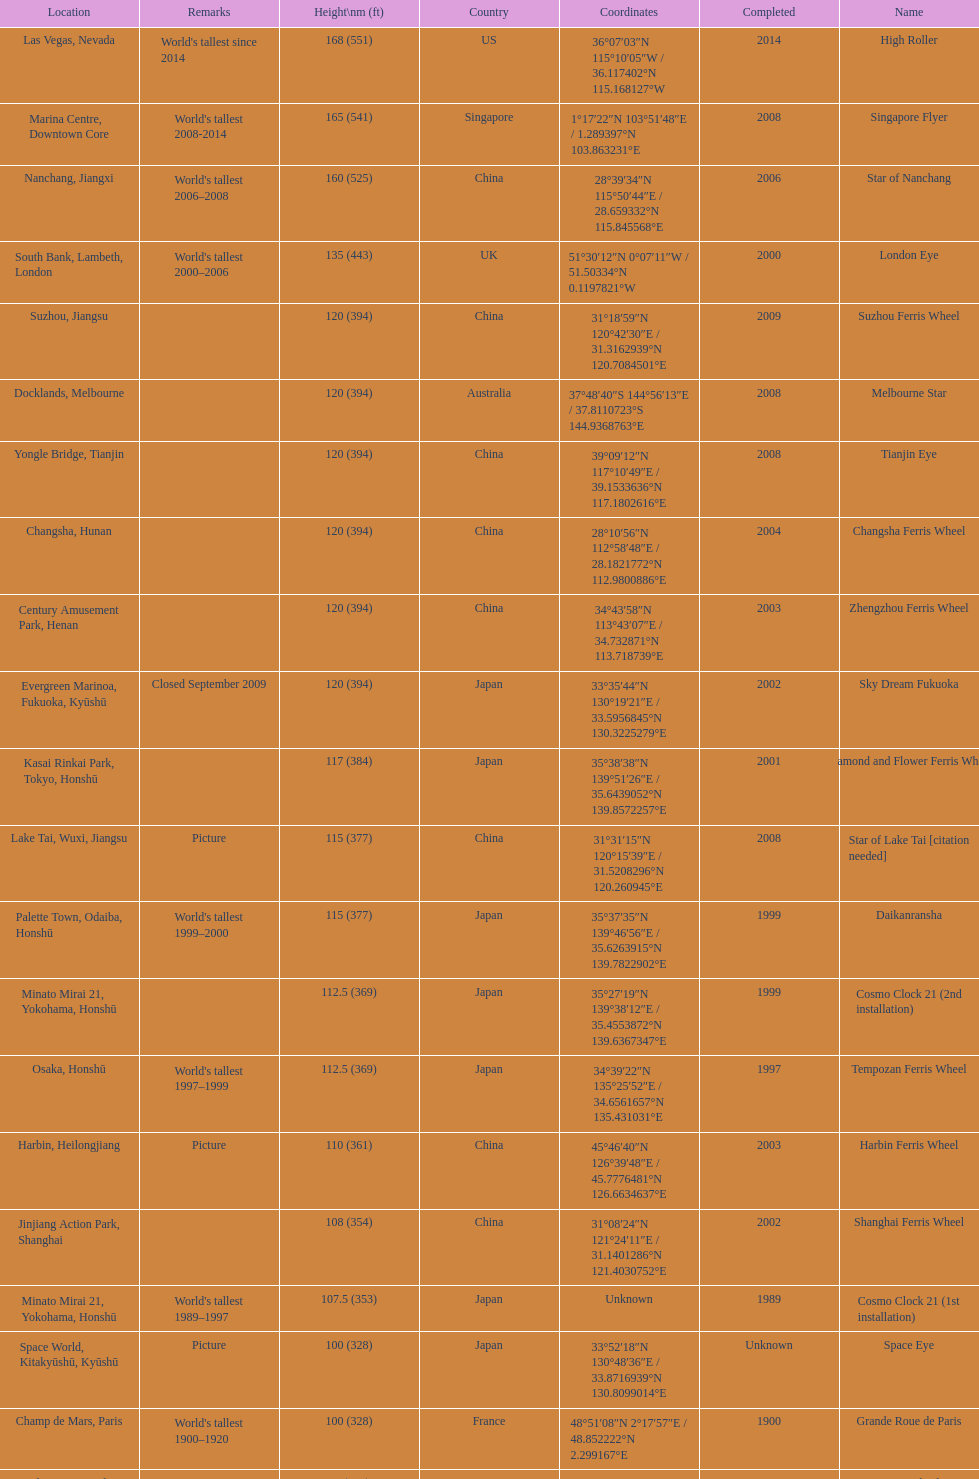Where was the original tallest roller coster built? Chicago. Could you parse the entire table as a dict? {'header': ['Location', 'Remarks', 'Height\\nm (ft)', 'Country', 'Coordinates', 'Completed', 'Name'], 'rows': [['Las Vegas, Nevada', "World's tallest since 2014", '168 (551)', 'US', '36°07′03″N 115°10′05″W\ufeff / \ufeff36.117402°N 115.168127°W', '2014', 'High Roller'], ['Marina Centre, Downtown Core', "World's tallest 2008-2014", '165 (541)', 'Singapore', '1°17′22″N 103°51′48″E\ufeff / \ufeff1.289397°N 103.863231°E', '2008', 'Singapore Flyer'], ['Nanchang, Jiangxi', "World's tallest 2006–2008", '160 (525)', 'China', '28°39′34″N 115°50′44″E\ufeff / \ufeff28.659332°N 115.845568°E', '2006', 'Star of Nanchang'], ['South Bank, Lambeth, London', "World's tallest 2000–2006", '135 (443)', 'UK', '51°30′12″N 0°07′11″W\ufeff / \ufeff51.50334°N 0.1197821°W', '2000', 'London Eye'], ['Suzhou, Jiangsu', '', '120 (394)', 'China', '31°18′59″N 120°42′30″E\ufeff / \ufeff31.3162939°N 120.7084501°E', '2009', 'Suzhou Ferris Wheel'], ['Docklands, Melbourne', '', '120 (394)', 'Australia', '37°48′40″S 144°56′13″E\ufeff / \ufeff37.8110723°S 144.9368763°E', '2008', 'Melbourne Star'], ['Yongle Bridge, Tianjin', '', '120 (394)', 'China', '39°09′12″N 117°10′49″E\ufeff / \ufeff39.1533636°N 117.1802616°E', '2008', 'Tianjin Eye'], ['Changsha, Hunan', '', '120 (394)', 'China', '28°10′56″N 112°58′48″E\ufeff / \ufeff28.1821772°N 112.9800886°E', '2004', 'Changsha Ferris Wheel'], ['Century Amusement Park, Henan', '', '120 (394)', 'China', '34°43′58″N 113°43′07″E\ufeff / \ufeff34.732871°N 113.718739°E', '2003', 'Zhengzhou Ferris Wheel'], ['Evergreen Marinoa, Fukuoka, Kyūshū', 'Closed September 2009', '120 (394)', 'Japan', '33°35′44″N 130°19′21″E\ufeff / \ufeff33.5956845°N 130.3225279°E', '2002', 'Sky Dream Fukuoka'], ['Kasai Rinkai Park, Tokyo, Honshū', '', '117 (384)', 'Japan', '35°38′38″N 139°51′26″E\ufeff / \ufeff35.6439052°N 139.8572257°E', '2001', 'Diamond\xa0and\xa0Flower\xa0Ferris\xa0Wheel'], ['Lake Tai, Wuxi, Jiangsu', 'Picture', '115 (377)', 'China', '31°31′15″N 120°15′39″E\ufeff / \ufeff31.5208296°N 120.260945°E', '2008', 'Star of Lake Tai\xa0[citation needed]'], ['Palette Town, Odaiba, Honshū', "World's tallest 1999–2000", '115 (377)', 'Japan', '35°37′35″N 139°46′56″E\ufeff / \ufeff35.6263915°N 139.7822902°E', '1999', 'Daikanransha'], ['Minato Mirai 21, Yokohama, Honshū', '', '112.5 (369)', 'Japan', '35°27′19″N 139°38′12″E\ufeff / \ufeff35.4553872°N 139.6367347°E', '1999', 'Cosmo Clock 21 (2nd installation)'], ['Osaka, Honshū', "World's tallest 1997–1999", '112.5 (369)', 'Japan', '34°39′22″N 135°25′52″E\ufeff / \ufeff34.6561657°N 135.431031°E', '1997', 'Tempozan Ferris Wheel'], ['Harbin, Heilongjiang', 'Picture', '110 (361)', 'China', '45°46′40″N 126°39′48″E\ufeff / \ufeff45.7776481°N 126.6634637°E', '2003', 'Harbin Ferris Wheel'], ['Jinjiang Action Park, Shanghai', '', '108 (354)', 'China', '31°08′24″N 121°24′11″E\ufeff / \ufeff31.1401286°N 121.4030752°E', '2002', 'Shanghai Ferris Wheel'], ['Minato Mirai 21, Yokohama, Honshū', "World's tallest 1989–1997", '107.5 (353)', 'Japan', 'Unknown', '1989', 'Cosmo Clock 21 (1st installation)'], ['Space World, Kitakyūshū, Kyūshū', 'Picture', '100 (328)', 'Japan', '33°52′18″N 130°48′36″E\ufeff / \ufeff33.8716939°N 130.8099014°E', 'Unknown', 'Space Eye'], ['Champ de Mars, Paris', "World's tallest 1900–1920", '100 (328)', 'France', '48°51′08″N 2°17′57″E\ufeff / \ufeff48.852222°N 2.299167°E', '1900', 'Grande Roue de Paris'], ['Earls Court, London', "World's tallest 1895–1900", '94 (308)', 'UK', '51°29′18″N 0°11′56″W\ufeff / \ufeff51.48835°N 0.19889°W', '1895', 'Great Wheel'], ['Nagashima Spa Land, Mie, Honshū', 'Picture', '90 (295)', 'Japan', '35°01′47″N 136°44′01″E\ufeff / \ufeff35.0298207°N 136.7336351°E', 'Unknown', 'Aurora Wheel'], ['Mirabilandia, Ravenna', '', '90 (295)', 'Italy', '44°20′21″N 12°15′44″E\ufeff / \ufeff44.3392161°N 12.2622228°E', '1999', 'Eurowheel'], ['Janfusun Fancyworld, Gukeng', '', '88 (289)', 'Taiwan', '23°37′13″N 120°34′35″E\ufeff / \ufeff23.6202611°N 120.5763352°E', 'Unknown', 'Sky Wheel'], ["Expoland, Osaka, Honshū (?-2009)\\nExpo '85, Tsukuba, Honshū (1985-?)", "Technocosmos renamed/relocated\\nWorld's tallest extant 1985–1989", '85 (279)', 'Japan', '34°48′14″N 135°32′09″E\ufeff / \ufeff34.803772°N 135.535916°E\\n36°03′40″N 140°04′23″E\ufeff / \ufeff36.061203°N 140.073055°E', '?\\n1985', 'Technostar\\nTechnocosmos'], ['Chicago (1893–1903); St. Louis (1904–06)', "World's tallest 1893–1894", '80.4 (264)', 'US', 'Ferris Wheel coordinates', '1893', 'The original Ferris Wheel']]} 